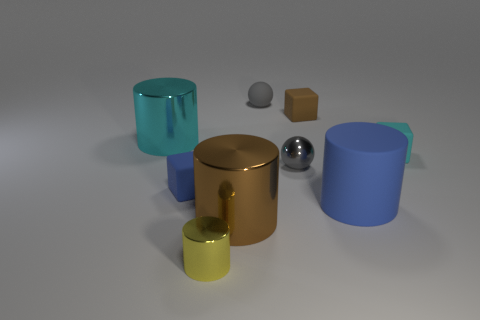There is a metallic object that is left of the small yellow cylinder; is its shape the same as the shiny object that is right of the gray rubber object?
Give a very brief answer. No. Are there any other things of the same color as the small shiny cylinder?
Offer a terse response. No. What is the shape of the big brown thing that is made of the same material as the small yellow object?
Offer a terse response. Cylinder. There is a small cube that is on the left side of the blue cylinder and behind the gray metal sphere; what material is it?
Keep it short and to the point. Rubber. Do the matte ball and the metal sphere have the same color?
Provide a short and direct response. Yes. The object that is the same color as the tiny rubber ball is what shape?
Offer a terse response. Sphere. What number of brown objects are the same shape as the large cyan thing?
Ensure brevity in your answer.  1. There is a cyan object that is made of the same material as the brown block; what size is it?
Provide a short and direct response. Small. Is the size of the blue cube the same as the blue rubber cylinder?
Provide a short and direct response. No. Are there any small objects?
Give a very brief answer. Yes. 